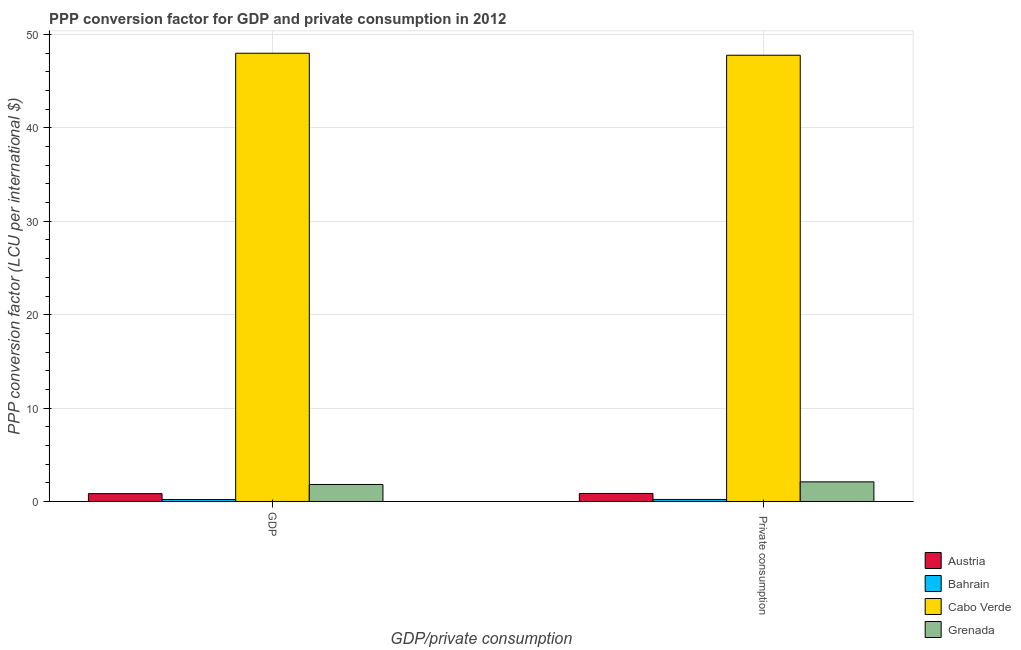How many different coloured bars are there?
Make the answer very short. 4. How many groups of bars are there?
Your answer should be compact. 2. How many bars are there on the 1st tick from the left?
Provide a short and direct response. 4. How many bars are there on the 1st tick from the right?
Provide a short and direct response. 4. What is the label of the 2nd group of bars from the left?
Ensure brevity in your answer.   Private consumption. What is the ppp conversion factor for private consumption in Grenada?
Your answer should be very brief. 2.1. Across all countries, what is the maximum ppp conversion factor for gdp?
Provide a succinct answer. 48. Across all countries, what is the minimum ppp conversion factor for private consumption?
Provide a short and direct response. 0.22. In which country was the ppp conversion factor for private consumption maximum?
Keep it short and to the point. Cabo Verde. In which country was the ppp conversion factor for gdp minimum?
Your response must be concise. Bahrain. What is the total ppp conversion factor for private consumption in the graph?
Your response must be concise. 50.96. What is the difference between the ppp conversion factor for private consumption in Grenada and that in Cabo Verde?
Keep it short and to the point. -45.69. What is the difference between the ppp conversion factor for private consumption in Grenada and the ppp conversion factor for gdp in Cabo Verde?
Your answer should be compact. -45.9. What is the average ppp conversion factor for private consumption per country?
Your response must be concise. 12.74. What is the difference between the ppp conversion factor for private consumption and ppp conversion factor for gdp in Bahrain?
Your answer should be compact. 0.01. What is the ratio of the ppp conversion factor for gdp in Austria to that in Bahrain?
Make the answer very short. 3.96. In how many countries, is the ppp conversion factor for gdp greater than the average ppp conversion factor for gdp taken over all countries?
Provide a succinct answer. 1. What does the 3rd bar from the left in  Private consumption represents?
Keep it short and to the point. Cabo Verde. What does the 4th bar from the right in  Private consumption represents?
Keep it short and to the point. Austria. Are all the bars in the graph horizontal?
Your response must be concise. No. What is the difference between two consecutive major ticks on the Y-axis?
Provide a succinct answer. 10. Are the values on the major ticks of Y-axis written in scientific E-notation?
Offer a very short reply. No. Does the graph contain any zero values?
Your answer should be compact. No. Does the graph contain grids?
Keep it short and to the point. Yes. How many legend labels are there?
Offer a terse response. 4. What is the title of the graph?
Your response must be concise. PPP conversion factor for GDP and private consumption in 2012. Does "Germany" appear as one of the legend labels in the graph?
Ensure brevity in your answer.  No. What is the label or title of the X-axis?
Ensure brevity in your answer.  GDP/private consumption. What is the label or title of the Y-axis?
Give a very brief answer. PPP conversion factor (LCU per international $). What is the PPP conversion factor (LCU per international $) of Austria in GDP?
Provide a succinct answer. 0.84. What is the PPP conversion factor (LCU per international $) in Bahrain in GDP?
Your answer should be compact. 0.21. What is the PPP conversion factor (LCU per international $) of Cabo Verde in GDP?
Your response must be concise. 48. What is the PPP conversion factor (LCU per international $) of Grenada in GDP?
Provide a succinct answer. 1.82. What is the PPP conversion factor (LCU per international $) of Austria in  Private consumption?
Offer a very short reply. 0.86. What is the PPP conversion factor (LCU per international $) in Bahrain in  Private consumption?
Your answer should be compact. 0.22. What is the PPP conversion factor (LCU per international $) of Cabo Verde in  Private consumption?
Give a very brief answer. 47.79. What is the PPP conversion factor (LCU per international $) in Grenada in  Private consumption?
Your answer should be compact. 2.1. Across all GDP/private consumption, what is the maximum PPP conversion factor (LCU per international $) of Austria?
Your response must be concise. 0.86. Across all GDP/private consumption, what is the maximum PPP conversion factor (LCU per international $) in Bahrain?
Make the answer very short. 0.22. Across all GDP/private consumption, what is the maximum PPP conversion factor (LCU per international $) of Cabo Verde?
Give a very brief answer. 48. Across all GDP/private consumption, what is the maximum PPP conversion factor (LCU per international $) in Grenada?
Your answer should be compact. 2.1. Across all GDP/private consumption, what is the minimum PPP conversion factor (LCU per international $) in Austria?
Your answer should be very brief. 0.84. Across all GDP/private consumption, what is the minimum PPP conversion factor (LCU per international $) of Bahrain?
Your response must be concise. 0.21. Across all GDP/private consumption, what is the minimum PPP conversion factor (LCU per international $) in Cabo Verde?
Offer a very short reply. 47.79. Across all GDP/private consumption, what is the minimum PPP conversion factor (LCU per international $) in Grenada?
Keep it short and to the point. 1.82. What is the total PPP conversion factor (LCU per international $) of Austria in the graph?
Provide a succinct answer. 1.7. What is the total PPP conversion factor (LCU per international $) of Bahrain in the graph?
Provide a short and direct response. 0.43. What is the total PPP conversion factor (LCU per international $) of Cabo Verde in the graph?
Your answer should be very brief. 95.78. What is the total PPP conversion factor (LCU per international $) of Grenada in the graph?
Offer a very short reply. 3.92. What is the difference between the PPP conversion factor (LCU per international $) in Austria in GDP and that in  Private consumption?
Ensure brevity in your answer.  -0.02. What is the difference between the PPP conversion factor (LCU per international $) in Bahrain in GDP and that in  Private consumption?
Your response must be concise. -0.01. What is the difference between the PPP conversion factor (LCU per international $) in Cabo Verde in GDP and that in  Private consumption?
Ensure brevity in your answer.  0.21. What is the difference between the PPP conversion factor (LCU per international $) of Grenada in GDP and that in  Private consumption?
Your answer should be compact. -0.28. What is the difference between the PPP conversion factor (LCU per international $) in Austria in GDP and the PPP conversion factor (LCU per international $) in Bahrain in  Private consumption?
Provide a succinct answer. 0.62. What is the difference between the PPP conversion factor (LCU per international $) in Austria in GDP and the PPP conversion factor (LCU per international $) in Cabo Verde in  Private consumption?
Offer a terse response. -46.95. What is the difference between the PPP conversion factor (LCU per international $) of Austria in GDP and the PPP conversion factor (LCU per international $) of Grenada in  Private consumption?
Your answer should be very brief. -1.26. What is the difference between the PPP conversion factor (LCU per international $) of Bahrain in GDP and the PPP conversion factor (LCU per international $) of Cabo Verde in  Private consumption?
Offer a very short reply. -47.57. What is the difference between the PPP conversion factor (LCU per international $) of Bahrain in GDP and the PPP conversion factor (LCU per international $) of Grenada in  Private consumption?
Offer a terse response. -1.89. What is the difference between the PPP conversion factor (LCU per international $) in Cabo Verde in GDP and the PPP conversion factor (LCU per international $) in Grenada in  Private consumption?
Ensure brevity in your answer.  45.9. What is the average PPP conversion factor (LCU per international $) of Austria per GDP/private consumption?
Make the answer very short. 0.85. What is the average PPP conversion factor (LCU per international $) of Bahrain per GDP/private consumption?
Offer a terse response. 0.21. What is the average PPP conversion factor (LCU per international $) of Cabo Verde per GDP/private consumption?
Offer a very short reply. 47.89. What is the average PPP conversion factor (LCU per international $) of Grenada per GDP/private consumption?
Provide a succinct answer. 1.96. What is the difference between the PPP conversion factor (LCU per international $) of Austria and PPP conversion factor (LCU per international $) of Bahrain in GDP?
Provide a short and direct response. 0.63. What is the difference between the PPP conversion factor (LCU per international $) of Austria and PPP conversion factor (LCU per international $) of Cabo Verde in GDP?
Your answer should be compact. -47.16. What is the difference between the PPP conversion factor (LCU per international $) in Austria and PPP conversion factor (LCU per international $) in Grenada in GDP?
Your answer should be compact. -0.98. What is the difference between the PPP conversion factor (LCU per international $) of Bahrain and PPP conversion factor (LCU per international $) of Cabo Verde in GDP?
Your answer should be compact. -47.79. What is the difference between the PPP conversion factor (LCU per international $) of Bahrain and PPP conversion factor (LCU per international $) of Grenada in GDP?
Your response must be concise. -1.61. What is the difference between the PPP conversion factor (LCU per international $) of Cabo Verde and PPP conversion factor (LCU per international $) of Grenada in GDP?
Offer a terse response. 46.18. What is the difference between the PPP conversion factor (LCU per international $) in Austria and PPP conversion factor (LCU per international $) in Bahrain in  Private consumption?
Give a very brief answer. 0.64. What is the difference between the PPP conversion factor (LCU per international $) of Austria and PPP conversion factor (LCU per international $) of Cabo Verde in  Private consumption?
Make the answer very short. -46.93. What is the difference between the PPP conversion factor (LCU per international $) of Austria and PPP conversion factor (LCU per international $) of Grenada in  Private consumption?
Offer a terse response. -1.24. What is the difference between the PPP conversion factor (LCU per international $) in Bahrain and PPP conversion factor (LCU per international $) in Cabo Verde in  Private consumption?
Your answer should be very brief. -47.57. What is the difference between the PPP conversion factor (LCU per international $) in Bahrain and PPP conversion factor (LCU per international $) in Grenada in  Private consumption?
Your response must be concise. -1.88. What is the difference between the PPP conversion factor (LCU per international $) in Cabo Verde and PPP conversion factor (LCU per international $) in Grenada in  Private consumption?
Keep it short and to the point. 45.69. What is the ratio of the PPP conversion factor (LCU per international $) in Austria in GDP to that in  Private consumption?
Your response must be concise. 0.98. What is the ratio of the PPP conversion factor (LCU per international $) in Bahrain in GDP to that in  Private consumption?
Your answer should be compact. 0.98. What is the ratio of the PPP conversion factor (LCU per international $) in Cabo Verde in GDP to that in  Private consumption?
Make the answer very short. 1. What is the ratio of the PPP conversion factor (LCU per international $) of Grenada in GDP to that in  Private consumption?
Give a very brief answer. 0.87. What is the difference between the highest and the second highest PPP conversion factor (LCU per international $) of Austria?
Ensure brevity in your answer.  0.02. What is the difference between the highest and the second highest PPP conversion factor (LCU per international $) in Bahrain?
Your answer should be very brief. 0.01. What is the difference between the highest and the second highest PPP conversion factor (LCU per international $) in Cabo Verde?
Provide a short and direct response. 0.21. What is the difference between the highest and the second highest PPP conversion factor (LCU per international $) of Grenada?
Your answer should be compact. 0.28. What is the difference between the highest and the lowest PPP conversion factor (LCU per international $) in Bahrain?
Offer a terse response. 0.01. What is the difference between the highest and the lowest PPP conversion factor (LCU per international $) of Cabo Verde?
Make the answer very short. 0.21. What is the difference between the highest and the lowest PPP conversion factor (LCU per international $) in Grenada?
Your answer should be compact. 0.28. 